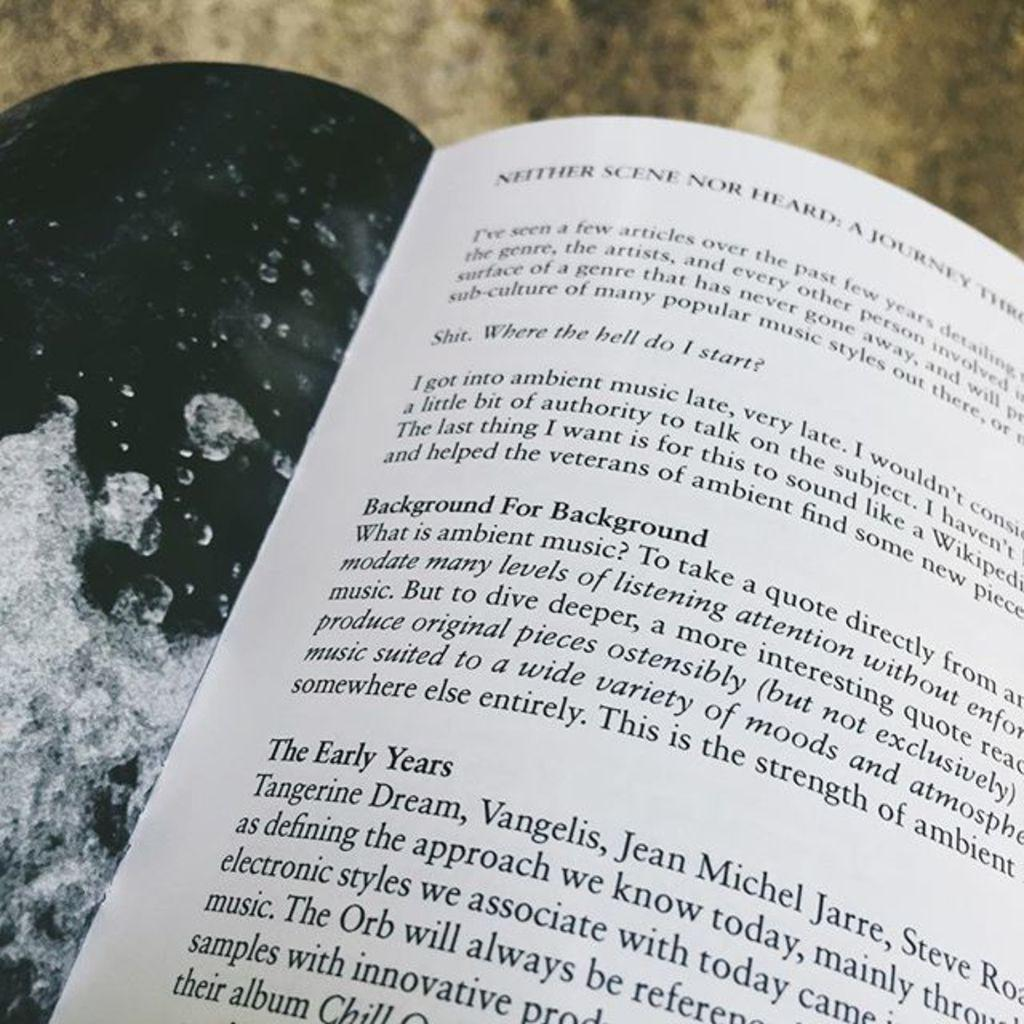<image>
Give a short and clear explanation of the subsequent image. An open book titled Neither Scene Nor Heard. 